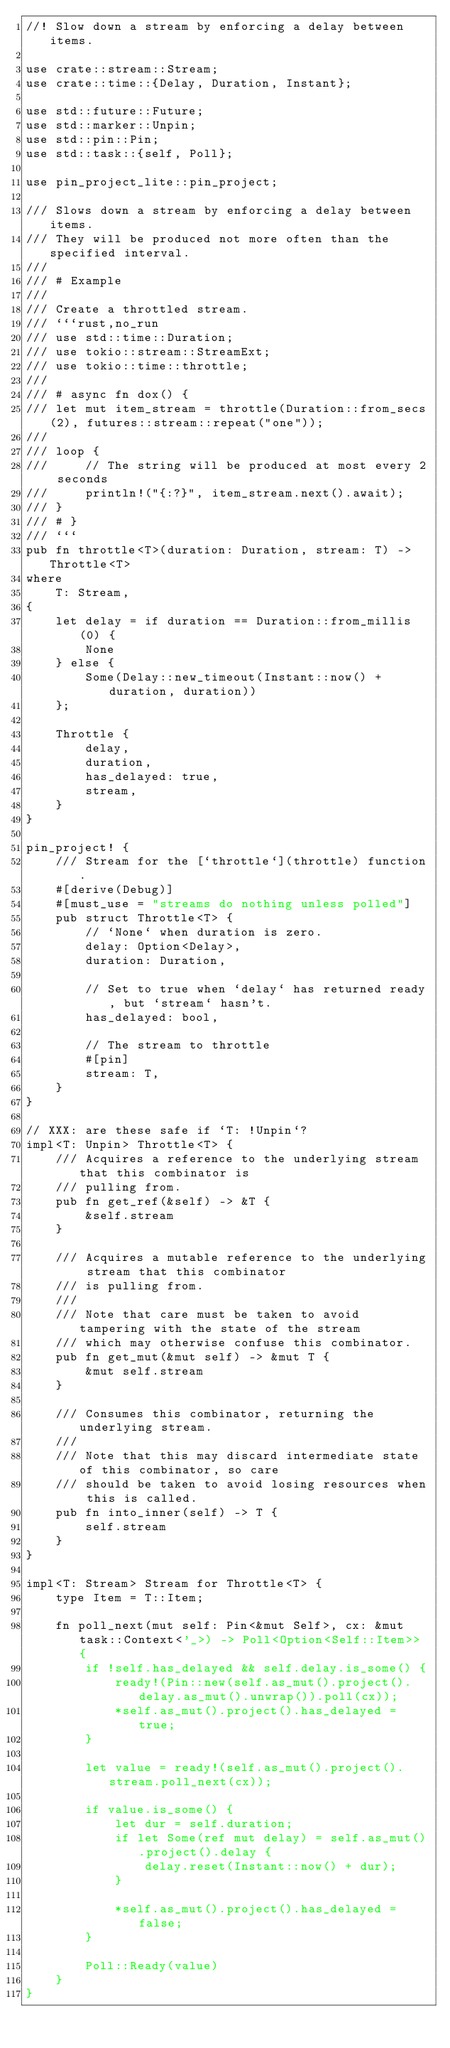Convert code to text. <code><loc_0><loc_0><loc_500><loc_500><_Rust_>//! Slow down a stream by enforcing a delay between items.

use crate::stream::Stream;
use crate::time::{Delay, Duration, Instant};

use std::future::Future;
use std::marker::Unpin;
use std::pin::Pin;
use std::task::{self, Poll};

use pin_project_lite::pin_project;

/// Slows down a stream by enforcing a delay between items.
/// They will be produced not more often than the specified interval.
///
/// # Example
///
/// Create a throttled stream.
/// ```rust,no_run
/// use std::time::Duration;
/// use tokio::stream::StreamExt;
/// use tokio::time::throttle;
///
/// # async fn dox() {
/// let mut item_stream = throttle(Duration::from_secs(2), futures::stream::repeat("one"));
///
/// loop {
///     // The string will be produced at most every 2 seconds
///     println!("{:?}", item_stream.next().await);
/// }
/// # }
/// ```
pub fn throttle<T>(duration: Duration, stream: T) -> Throttle<T>
where
    T: Stream,
{
    let delay = if duration == Duration::from_millis(0) {
        None
    } else {
        Some(Delay::new_timeout(Instant::now() + duration, duration))
    };

    Throttle {
        delay,
        duration,
        has_delayed: true,
        stream,
    }
}

pin_project! {
    /// Stream for the [`throttle`](throttle) function.
    #[derive(Debug)]
    #[must_use = "streams do nothing unless polled"]
    pub struct Throttle<T> {
        // `None` when duration is zero.
        delay: Option<Delay>,
        duration: Duration,

        // Set to true when `delay` has returned ready, but `stream` hasn't.
        has_delayed: bool,

        // The stream to throttle
        #[pin]
        stream: T,
    }
}

// XXX: are these safe if `T: !Unpin`?
impl<T: Unpin> Throttle<T> {
    /// Acquires a reference to the underlying stream that this combinator is
    /// pulling from.
    pub fn get_ref(&self) -> &T {
        &self.stream
    }

    /// Acquires a mutable reference to the underlying stream that this combinator
    /// is pulling from.
    ///
    /// Note that care must be taken to avoid tampering with the state of the stream
    /// which may otherwise confuse this combinator.
    pub fn get_mut(&mut self) -> &mut T {
        &mut self.stream
    }

    /// Consumes this combinator, returning the underlying stream.
    ///
    /// Note that this may discard intermediate state of this combinator, so care
    /// should be taken to avoid losing resources when this is called.
    pub fn into_inner(self) -> T {
        self.stream
    }
}

impl<T: Stream> Stream for Throttle<T> {
    type Item = T::Item;

    fn poll_next(mut self: Pin<&mut Self>, cx: &mut task::Context<'_>) -> Poll<Option<Self::Item>> {
        if !self.has_delayed && self.delay.is_some() {
            ready!(Pin::new(self.as_mut().project().delay.as_mut().unwrap()).poll(cx));
            *self.as_mut().project().has_delayed = true;
        }

        let value = ready!(self.as_mut().project().stream.poll_next(cx));

        if value.is_some() {
            let dur = self.duration;
            if let Some(ref mut delay) = self.as_mut().project().delay {
                delay.reset(Instant::now() + dur);
            }

            *self.as_mut().project().has_delayed = false;
        }

        Poll::Ready(value)
    }
}
</code> 